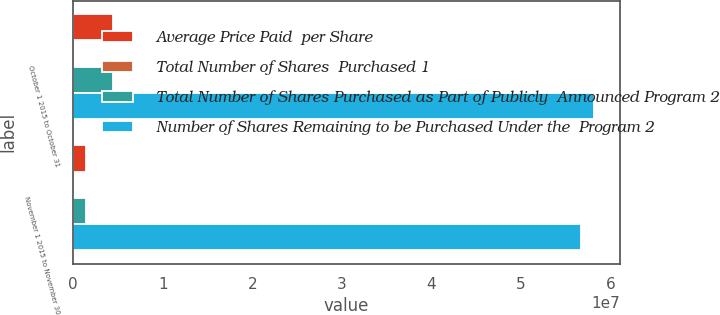Convert chart to OTSL. <chart><loc_0><loc_0><loc_500><loc_500><stacked_bar_chart><ecel><fcel>October 1 2015 to October 31<fcel>November 1 2015 to November 30<nl><fcel>Average Price Paid  per Share<fcel>4.42589e+06<fcel>1.44099e+06<nl><fcel>Total Number of Shares  Purchased 1<fcel>43.98<fcel>39.76<nl><fcel>Total Number of Shares Purchased as Part of Publicly  Announced Program 2<fcel>4.42403e+06<fcel>1.44099e+06<nl><fcel>Number of Shares Remaining to be Purchased Under the  Program 2<fcel>5.81104e+07<fcel>5.66694e+07<nl></chart> 